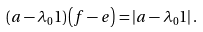Convert formula to latex. <formula><loc_0><loc_0><loc_500><loc_500>\left ( a - \lambda _ { 0 } 1 \right ) \left ( f - e \right ) = \left | a - \lambda _ { 0 } 1 \right | .</formula> 